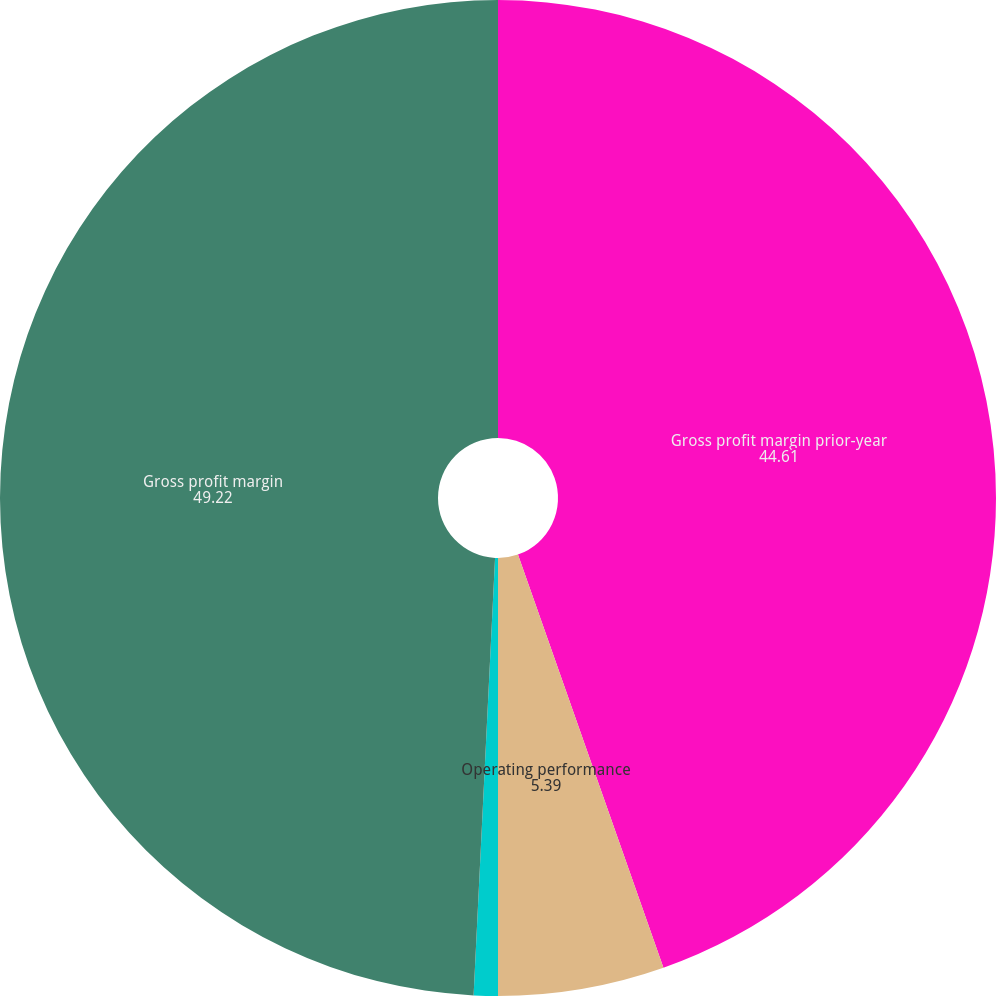Convert chart to OTSL. <chart><loc_0><loc_0><loc_500><loc_500><pie_chart><fcel>Gross profit margin prior-year<fcel>Operating performance<fcel>Foreign currency translation<fcel>Gross profit margin<nl><fcel>44.61%<fcel>5.39%<fcel>0.78%<fcel>49.22%<nl></chart> 